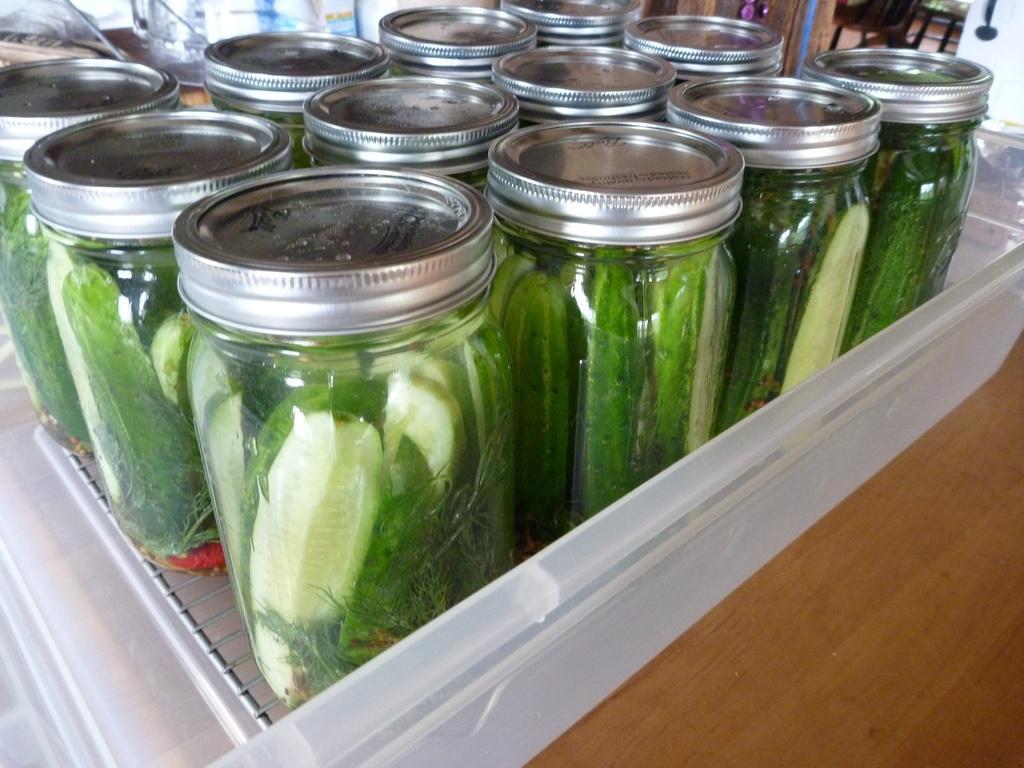Can you describe this image briefly? In this image I can see the box with jars. I can see the cream and green color items inside the jars. The box is on the brown color surface. To the side I can see few more objects. 